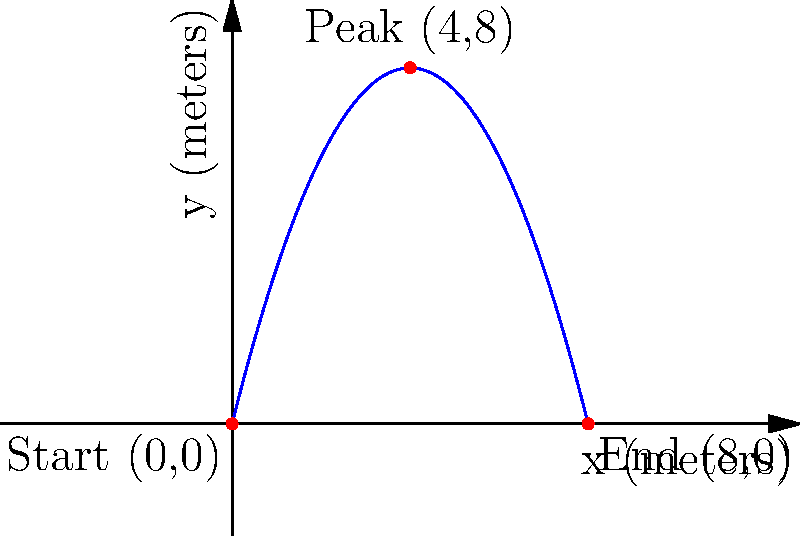A diver performs a somersault with the trajectory shown in the 2D coordinate system above. The x-axis represents the horizontal distance from the diving board, and the y-axis represents the height above the water. The diver's path can be modeled by the equation $y = -0.5x^2 + 4x$, where $x$ and $y$ are measured in meters. Calculate the horizontal distance traveled by the diver from the start of the dive to the point where they reach maximum height. To find the horizontal distance to the point of maximum height, we need to follow these steps:

1) The trajectory is given by the quadratic equation $y = -0.5x^2 + 4x$.

2) The maximum height occurs at the vertex of this parabola. For a quadratic equation in the form $y = ax^2 + bx + c$, the x-coordinate of the vertex is given by $x = -\frac{b}{2a}$.

3) In our equation, $a = -0.5$ and $b = 4$. Let's substitute these values:

   $x = -\frac{4}{2(-0.5)} = -\frac{4}{-1} = 4$

4) Therefore, the diver reaches maximum height when $x = 4$ meters.

5) Since the diver starts at $x = 0$, the horizontal distance traveled to the point of maximum height is 4 meters.

This result can be visually confirmed in the graph, where we see the peak of the trajectory occurs at $x = 4$.
Answer: 4 meters 